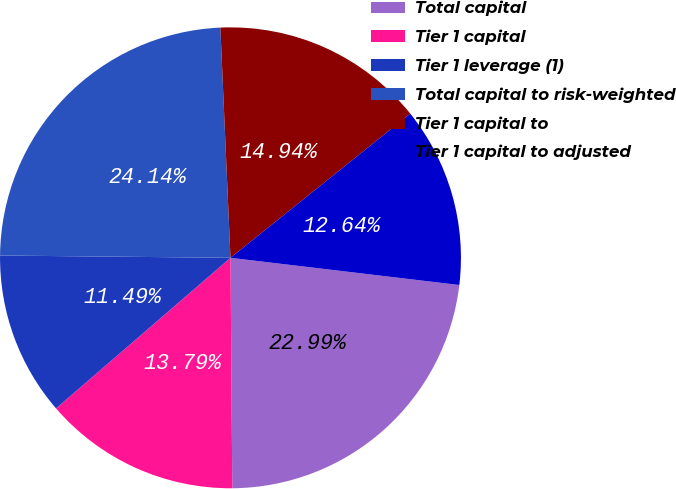<chart> <loc_0><loc_0><loc_500><loc_500><pie_chart><fcel>Total capital<fcel>Tier 1 capital<fcel>Tier 1 leverage (1)<fcel>Total capital to risk-weighted<fcel>Tier 1 capital to<fcel>Tier 1 capital to adjusted<nl><fcel>22.99%<fcel>13.79%<fcel>11.49%<fcel>24.14%<fcel>14.94%<fcel>12.64%<nl></chart> 